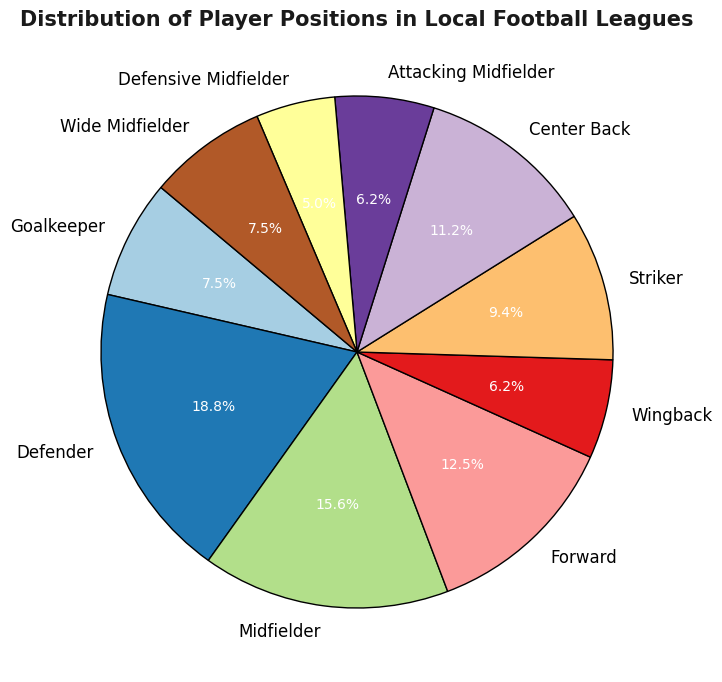What percentage of players are Defenders? From the pie chart, locate the segment labeled "Defender" and read the percentage value associated with it.
Answer: 21.1% How many more Defenders are there compared to Goalkeepers? Look at the counts for both Defenders (30) and Goalkeepers (12). Subtract the number of Goalkeepers from the number of Defenders: 30 - 12 = 18
Answer: 18 Which position has the least number of players, and what is the percentage? Identify the segment with the smallest percentage. In this chart, it is "Defensive Midfielder" with 8 players. Calculate its percentage: (8 / (12 + 30 + 25 + 20 + 10 + 15 + 18 + 10 + 8 + 12)) * 100 ≈ 5.6%
Answer: Defensive Midfielder, 5.6% What is the total percentage of Midfielders, if we sum up Midfielders, Attacking Midfielders, Defensive Midfielders, and Wide Midfielders? Add counts for each midfield position: Midfielder (25), Attacking Midfielder (10), Defensive Midfielder (8), Wide Midfielder (12). Calculate total players: 25 + 10 + 8 + 12 = 55. Then, find the percentage: (55 / (12+30+25+20+10+15+18+10+8+12)) * 100 ≈ 38.7%
Answer: 38.7% Which position has the closest number of players to Strikers? Check the counts: Striker (15). Compare it with other counts. Center Back (18) is closest because it's the smallest difference: 18 - 15 = 3.
Answer: Center Back What are the two most populated positions? Identify the two segments with the highest counts: Defender (30) and Midfielder (25).
Answer: Defender, Midfielder Calculate the difference in percentage between Forwards and Wingbacks. Look at the counts: Forward (20) and Wingback (10). Calculate their percentages: (20 / 160) * 100 ≈ 12.5% and (10 / 160) * 100 ≈ 6.3%. Difference: 12.5% - 6.3% = 6.2%
Answer: 6.2% How many positions have more than 10 players? Count the segments with more than 10 players: Goalkeeper, Defender, Midfielder, Forward, Striker, Center Back, Wide Midfielder (7 positions).
Answer: 7 